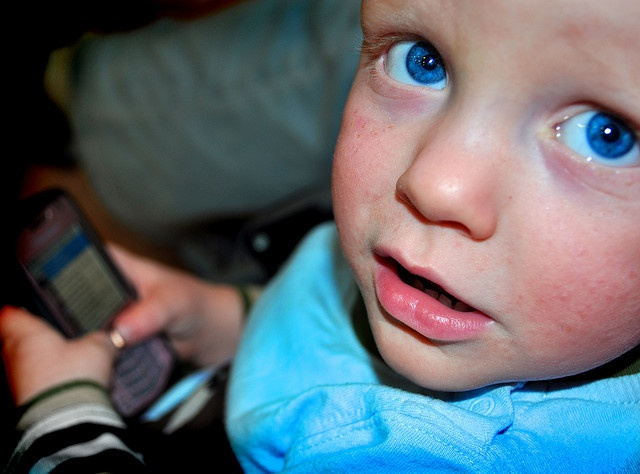Describe the objects in this image and their specific colors. I can see people in black, lightpink, darkgray, and brown tones and cell phone in black, gray, and navy tones in this image. 